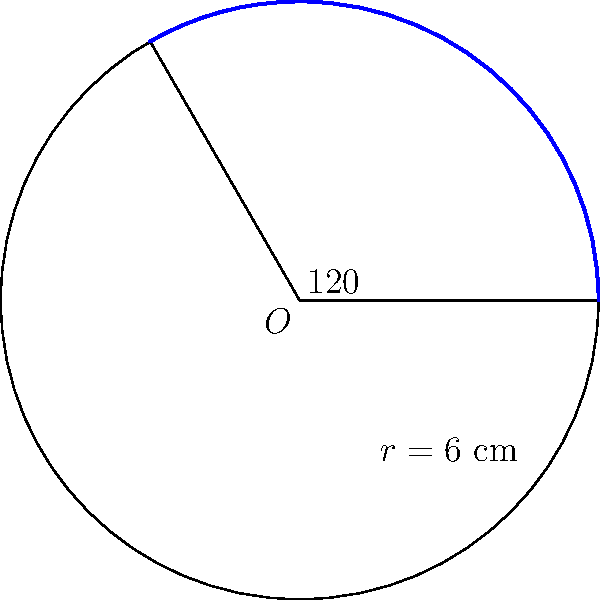During your physical therapy sessions, you're working on visualizing geometric shapes to maintain mental acuity. Consider a circular training field with a radius of 6 cm. If you were to run along an arc that forms a central angle of 120°, what would be the area of the sector formed by this arc and the two radii? Let's approach this step-by-step:

1) The formula for the area of a circular sector is:

   $$A = \frac{\theta}{360°} \pi r^2$$

   Where $\theta$ is the central angle in degrees, and $r$ is the radius.

2) We're given:
   - Radius ($r$) = 6 cm
   - Central angle ($\theta$) = 120°

3) Let's substitute these values into our formula:

   $$A = \frac{120°}{360°} \pi (6 \text{ cm})^2$$

4) Simplify the fraction:

   $$A = \frac{1}{3} \pi (6 \text{ cm})^2$$

5) Calculate the square of the radius:

   $$A = \frac{1}{3} \pi (36 \text{ cm}^2)$$

6) Multiply:

   $$A = 12\pi \text{ cm}^2$$

Therefore, the area of the sector is $12\pi$ square centimeters.
Answer: $12\pi \text{ cm}^2$ 